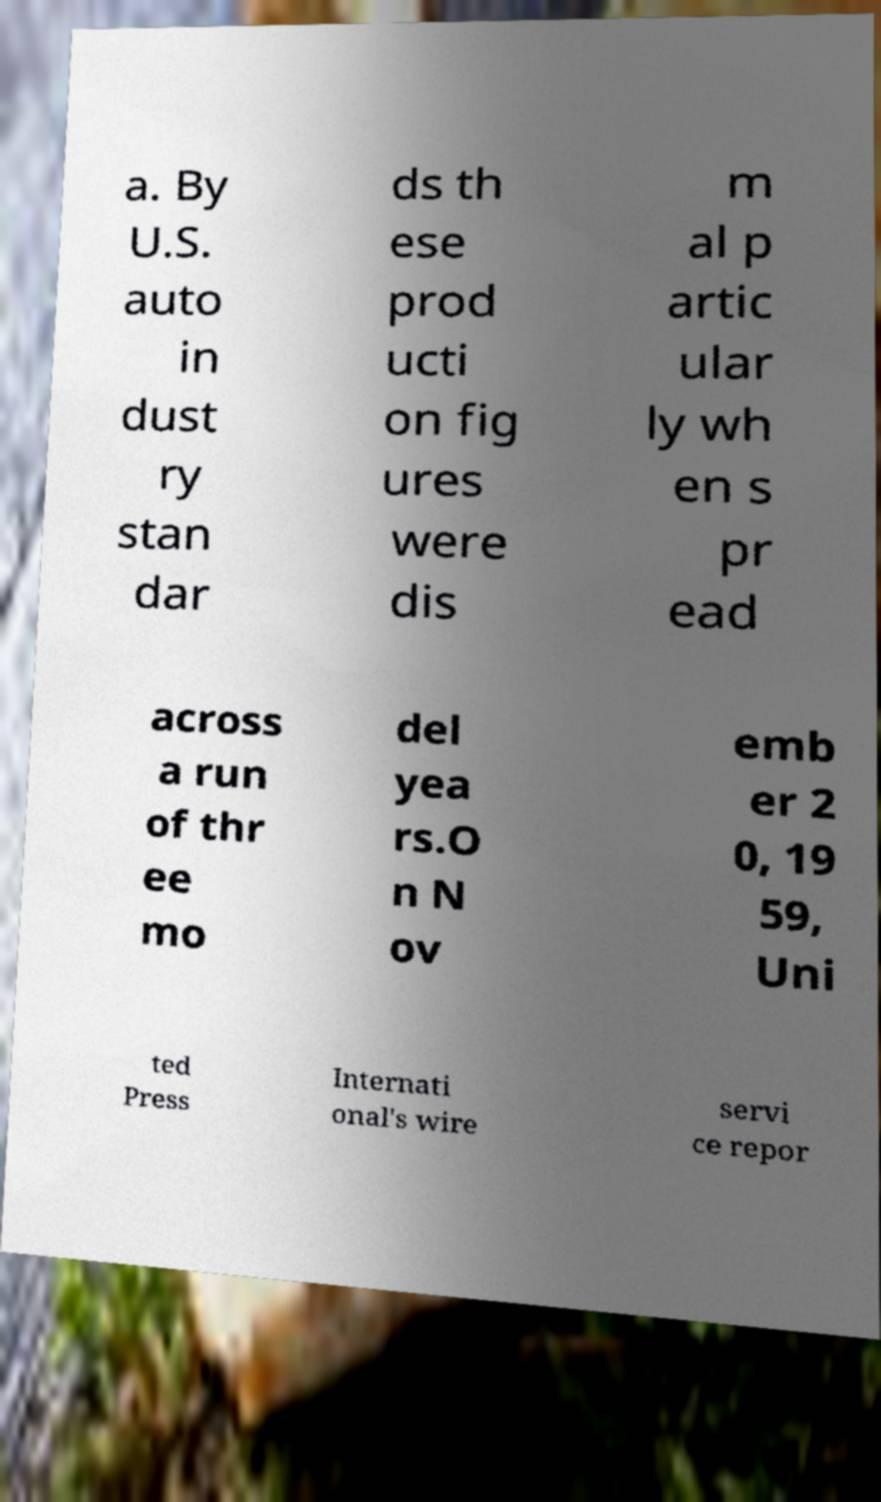For documentation purposes, I need the text within this image transcribed. Could you provide that? a. By U.S. auto in dust ry stan dar ds th ese prod ucti on fig ures were dis m al p artic ular ly wh en s pr ead across a run of thr ee mo del yea rs.O n N ov emb er 2 0, 19 59, Uni ted Press Internati onal's wire servi ce repor 